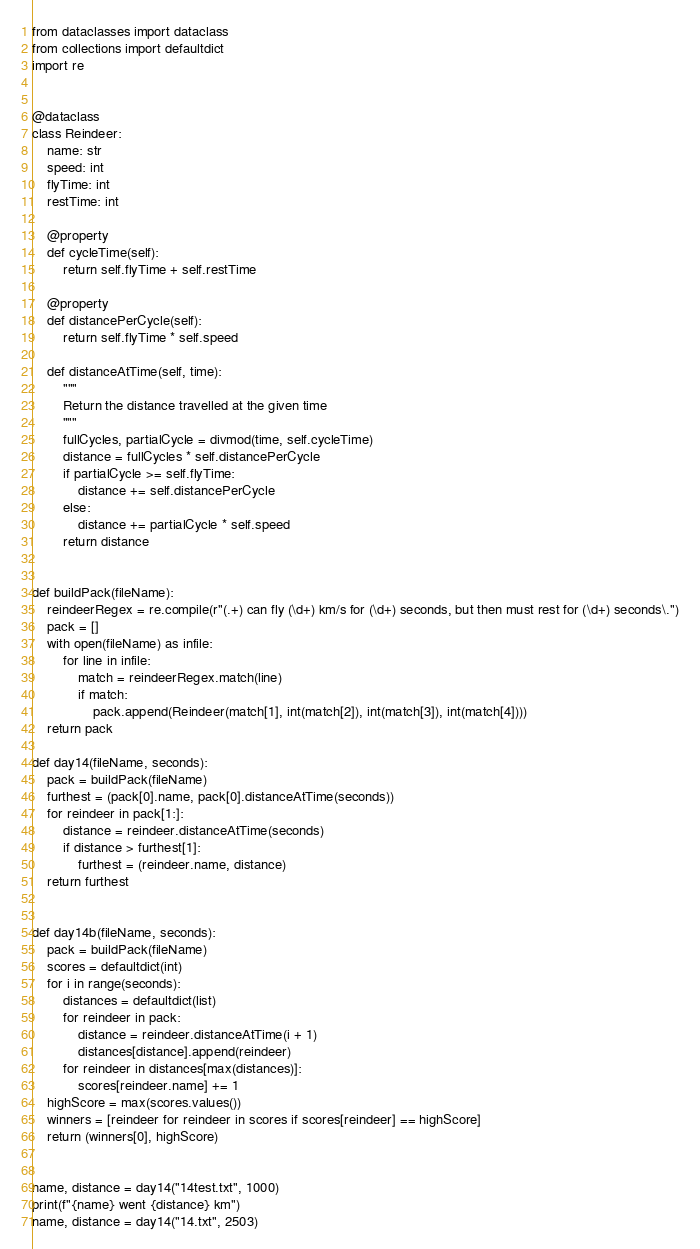<code> <loc_0><loc_0><loc_500><loc_500><_Python_>from dataclasses import dataclass
from collections import defaultdict
import re


@dataclass
class Reindeer:
    name: str
    speed: int
    flyTime: int
    restTime: int

    @property
    def cycleTime(self):
        return self.flyTime + self.restTime

    @property
    def distancePerCycle(self):
        return self.flyTime * self.speed

    def distanceAtTime(self, time):
        """
        Return the distance travelled at the given time
        """
        fullCycles, partialCycle = divmod(time, self.cycleTime)
        distance = fullCycles * self.distancePerCycle
        if partialCycle >= self.flyTime:
            distance += self.distancePerCycle
        else:
            distance += partialCycle * self.speed
        return distance


def buildPack(fileName):
    reindeerRegex = re.compile(r"(.+) can fly (\d+) km/s for (\d+) seconds, but then must rest for (\d+) seconds\.")
    pack = []
    with open(fileName) as infile:
        for line in infile:
            match = reindeerRegex.match(line)
            if match:
                pack.append(Reindeer(match[1], int(match[2]), int(match[3]), int(match[4])))
    return pack

def day14(fileName, seconds):
    pack = buildPack(fileName)
    furthest = (pack[0].name, pack[0].distanceAtTime(seconds))
    for reindeer in pack[1:]:
        distance = reindeer.distanceAtTime(seconds)
        if distance > furthest[1]:
            furthest = (reindeer.name, distance)
    return furthest


def day14b(fileName, seconds):
    pack = buildPack(fileName)
    scores = defaultdict(int)
    for i in range(seconds):
        distances = defaultdict(list)
        for reindeer in pack:
            distance = reindeer.distanceAtTime(i + 1)
            distances[distance].append(reindeer)
        for reindeer in distances[max(distances)]:
            scores[reindeer.name] += 1
    highScore = max(scores.values())
    winners = [reindeer for reindeer in scores if scores[reindeer] == highScore]
    return (winners[0], highScore)


name, distance = day14("14test.txt", 1000)
print(f"{name} went {distance} km")
name, distance = day14("14.txt", 2503)</code> 